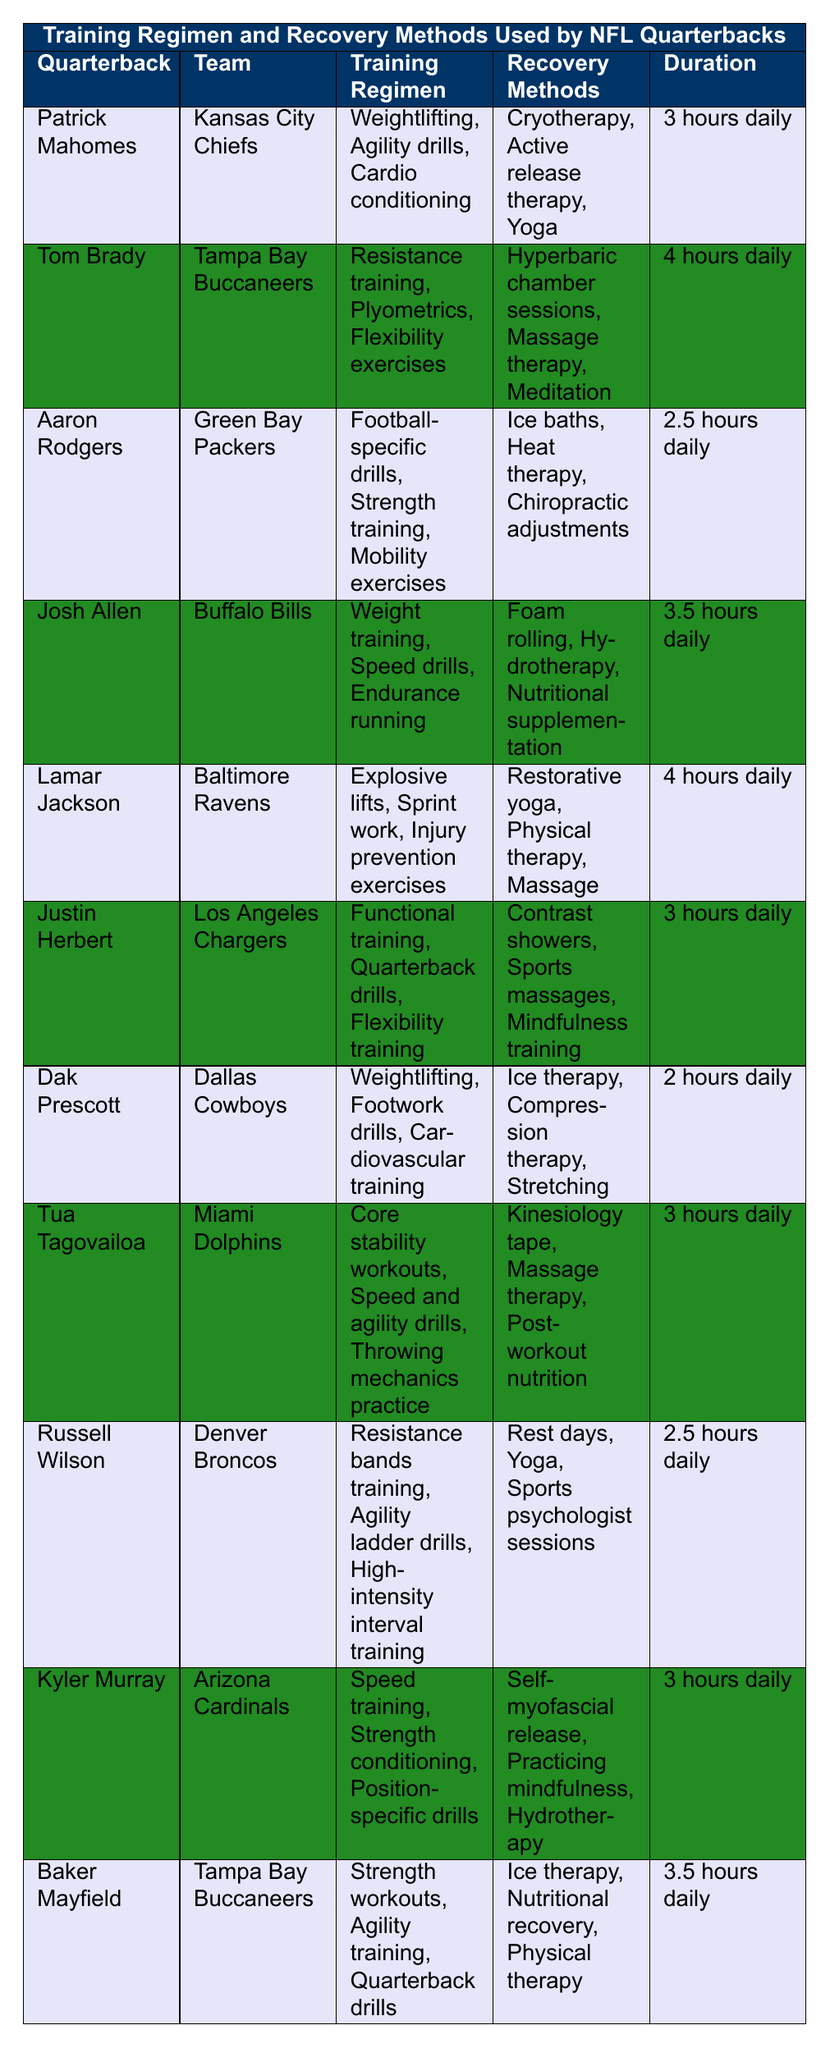What is the longest training duration among the quarterbacks listed? To find the longest training duration, I will compare the durations mentioned for each quarterback: 3, 4, 2.5, 3.5, 4, 3, 2, 3, 2.5, 3, and 3.5 hours daily. The maximum value among these is 4 hours, associated with Tom Brady and Lamar Jackson.
Answer: 4 hours Which quarterback from the Tampa Bay Buccaneers has the most recovery methods listed? There are two quarterbacks from the Tampa Bay Buccaneers: Tom Brady and Baker Mayfield. Tom Brady’s recovery methods are three: hyperbaric chamber sessions, massage therapy, and meditation. Baker Mayfield has three as well: ice therapy, nutritional recovery, and physical therapy. Both have the same number of recovery methods.
Answer: Both have three recovery methods How many quarterbacks include 'Yoga' as part of their recovery methods? I will check the recovery methods for each quarterback in the table to count how many include 'Yoga.' Patrick Mahomes and Lamar Jackson have 'Yoga' listed, making a total of two quarterbacks.
Answer: 2 What training regimens are shared by more than one quarterback? I will list the training regimens from each quarterback: Weightlifting, Agility drills, and others. Checking through them, I find that Weightlifting appears for both Patrick Mahomes and Dak Prescott. Thus, Weightlifting is a common training regimen.
Answer: Weightlifting Who spends the least amount of time training? I will check the durations for all quarterbacks and find the minimum value. The durations listed are: 3, 4, 2.5, 3.5, 4, 3, 2, 3, 2.5, 3, and 3.5 hours daily. The least duration is 2 hours daily, associated with Dak Prescott.
Answer: Dak Prescott What proportion of quarterbacks use 'Massage therapy' as a recovery method? There are 11 quarterbacks listed. I will check who mentions 'Massage therapy' among their recovery methods. It appears in 3 instances (Tom Brady, Lamar Jackson, and Tua Tagovailoa). To find the proportion, I calculate 3 out of 11, which gives approximately 0.27 or 27%.
Answer: 27% Which team has a quarterback that practices 'Contrast showers'? I will look through the recovery methods listed for each quarterback and find 'Contrast showers.' This method is associated with Justin Herbert from the Los Angeles Chargers.
Answer: Los Angeles Chargers What is the average training duration among the quarterbacks? I will first sum the durations: 3, 4, 2.5, 3.5, 4, 3, 2, 3, 2.5, 3, and 3.5 hours. The total is 32 hours. There are 11 quarterbacks, so the average is 32/11, which is approximately 2.91 hours.
Answer: 2.91 hours Which recovery method is unique to Dak Prescott? To determine this, I will check Dak Prescott’s recovery methods: ice therapy, compression therapy, and stretching. I'll compare these against all other quarterbacks’ recovery methods. Ice therapy appears for others (Baker Mayfield), as does stretching. Compression therapy is exclusive to Dak Prescott.
Answer: Compression therapy How many quarterbacks' training regimens include 'Agility drills'? I will look at the training regimens: Patrick Mahomes includes it, and so does Baker Mayfield. Thus, it is included in two training regimens.
Answer: 2 